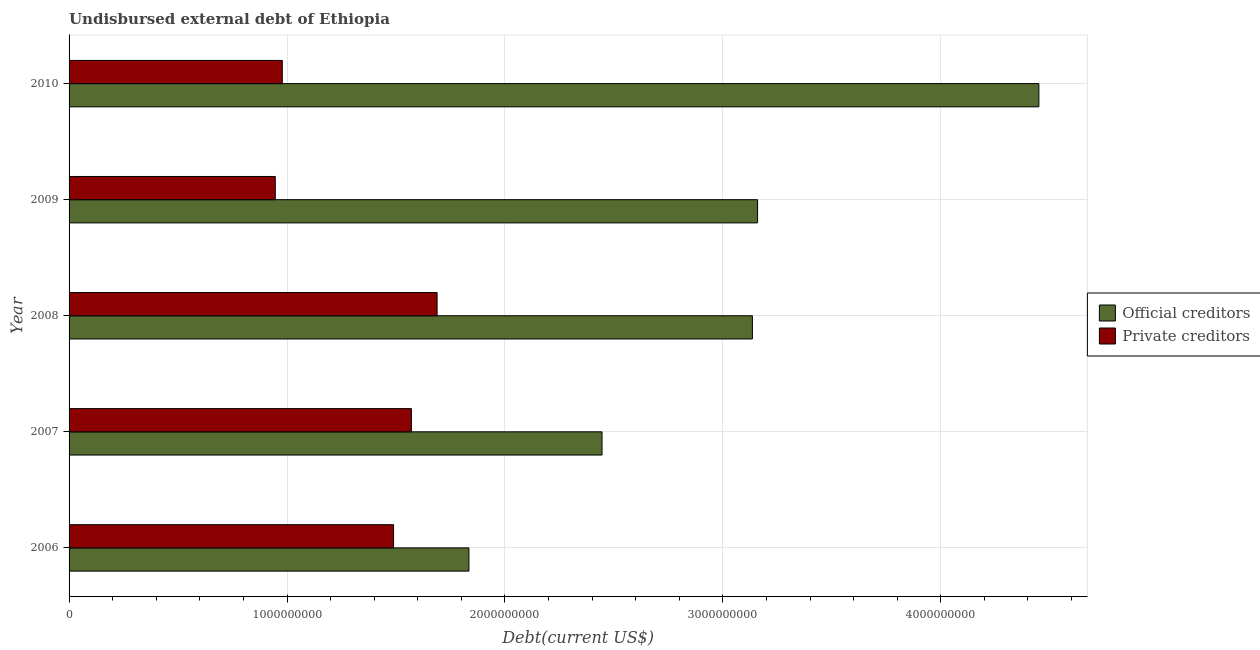How many groups of bars are there?
Provide a succinct answer. 5. Are the number of bars on each tick of the Y-axis equal?
Ensure brevity in your answer.  Yes. How many bars are there on the 5th tick from the top?
Offer a terse response. 2. What is the label of the 5th group of bars from the top?
Your answer should be very brief. 2006. In how many cases, is the number of bars for a given year not equal to the number of legend labels?
Your answer should be very brief. 0. What is the undisbursed external debt of private creditors in 2009?
Provide a short and direct response. 9.46e+08. Across all years, what is the maximum undisbursed external debt of private creditors?
Offer a terse response. 1.69e+09. Across all years, what is the minimum undisbursed external debt of private creditors?
Provide a short and direct response. 9.46e+08. In which year was the undisbursed external debt of private creditors maximum?
Your answer should be very brief. 2008. In which year was the undisbursed external debt of private creditors minimum?
Your answer should be compact. 2009. What is the total undisbursed external debt of private creditors in the graph?
Provide a succinct answer. 6.67e+09. What is the difference between the undisbursed external debt of official creditors in 2007 and that in 2008?
Give a very brief answer. -6.90e+08. What is the difference between the undisbursed external debt of private creditors in 2010 and the undisbursed external debt of official creditors in 2008?
Offer a terse response. -2.16e+09. What is the average undisbursed external debt of official creditors per year?
Provide a short and direct response. 3.00e+09. In the year 2006, what is the difference between the undisbursed external debt of private creditors and undisbursed external debt of official creditors?
Keep it short and to the point. -3.46e+08. In how many years, is the undisbursed external debt of official creditors greater than 1600000000 US$?
Offer a terse response. 5. What is the ratio of the undisbursed external debt of private creditors in 2008 to that in 2009?
Ensure brevity in your answer.  1.78. What is the difference between the highest and the second highest undisbursed external debt of private creditors?
Provide a short and direct response. 1.18e+08. What is the difference between the highest and the lowest undisbursed external debt of official creditors?
Offer a very short reply. 2.62e+09. Is the sum of the undisbursed external debt of private creditors in 2006 and 2010 greater than the maximum undisbursed external debt of official creditors across all years?
Offer a very short reply. No. What does the 2nd bar from the top in 2006 represents?
Your answer should be compact. Official creditors. What does the 2nd bar from the bottom in 2008 represents?
Offer a terse response. Private creditors. How many bars are there?
Provide a succinct answer. 10. How many years are there in the graph?
Ensure brevity in your answer.  5. What is the title of the graph?
Your answer should be very brief. Undisbursed external debt of Ethiopia. What is the label or title of the X-axis?
Offer a terse response. Debt(current US$). What is the Debt(current US$) of Official creditors in 2006?
Offer a terse response. 1.83e+09. What is the Debt(current US$) of Private creditors in 2006?
Provide a succinct answer. 1.49e+09. What is the Debt(current US$) of Official creditors in 2007?
Offer a terse response. 2.45e+09. What is the Debt(current US$) of Private creditors in 2007?
Your response must be concise. 1.57e+09. What is the Debt(current US$) of Official creditors in 2008?
Provide a short and direct response. 3.14e+09. What is the Debt(current US$) in Private creditors in 2008?
Offer a terse response. 1.69e+09. What is the Debt(current US$) in Official creditors in 2009?
Your response must be concise. 3.16e+09. What is the Debt(current US$) of Private creditors in 2009?
Offer a very short reply. 9.46e+08. What is the Debt(current US$) in Official creditors in 2010?
Make the answer very short. 4.45e+09. What is the Debt(current US$) of Private creditors in 2010?
Your answer should be very brief. 9.78e+08. Across all years, what is the maximum Debt(current US$) of Official creditors?
Your answer should be very brief. 4.45e+09. Across all years, what is the maximum Debt(current US$) in Private creditors?
Provide a short and direct response. 1.69e+09. Across all years, what is the minimum Debt(current US$) of Official creditors?
Your response must be concise. 1.83e+09. Across all years, what is the minimum Debt(current US$) of Private creditors?
Ensure brevity in your answer.  9.46e+08. What is the total Debt(current US$) in Official creditors in the graph?
Your answer should be very brief. 1.50e+1. What is the total Debt(current US$) in Private creditors in the graph?
Your answer should be compact. 6.67e+09. What is the difference between the Debt(current US$) in Official creditors in 2006 and that in 2007?
Your response must be concise. -6.11e+08. What is the difference between the Debt(current US$) of Private creditors in 2006 and that in 2007?
Provide a short and direct response. -8.19e+07. What is the difference between the Debt(current US$) of Official creditors in 2006 and that in 2008?
Your response must be concise. -1.30e+09. What is the difference between the Debt(current US$) in Private creditors in 2006 and that in 2008?
Offer a terse response. -2.00e+08. What is the difference between the Debt(current US$) in Official creditors in 2006 and that in 2009?
Ensure brevity in your answer.  -1.32e+09. What is the difference between the Debt(current US$) in Private creditors in 2006 and that in 2009?
Provide a short and direct response. 5.43e+08. What is the difference between the Debt(current US$) of Official creditors in 2006 and that in 2010?
Offer a very short reply. -2.62e+09. What is the difference between the Debt(current US$) in Private creditors in 2006 and that in 2010?
Give a very brief answer. 5.10e+08. What is the difference between the Debt(current US$) in Official creditors in 2007 and that in 2008?
Make the answer very short. -6.90e+08. What is the difference between the Debt(current US$) in Private creditors in 2007 and that in 2008?
Offer a terse response. -1.18e+08. What is the difference between the Debt(current US$) of Official creditors in 2007 and that in 2009?
Give a very brief answer. -7.14e+08. What is the difference between the Debt(current US$) in Private creditors in 2007 and that in 2009?
Keep it short and to the point. 6.25e+08. What is the difference between the Debt(current US$) of Official creditors in 2007 and that in 2010?
Offer a terse response. -2.00e+09. What is the difference between the Debt(current US$) of Private creditors in 2007 and that in 2010?
Offer a very short reply. 5.92e+08. What is the difference between the Debt(current US$) of Official creditors in 2008 and that in 2009?
Your response must be concise. -2.38e+07. What is the difference between the Debt(current US$) in Private creditors in 2008 and that in 2009?
Keep it short and to the point. 7.42e+08. What is the difference between the Debt(current US$) in Official creditors in 2008 and that in 2010?
Your response must be concise. -1.31e+09. What is the difference between the Debt(current US$) in Private creditors in 2008 and that in 2010?
Offer a terse response. 7.10e+08. What is the difference between the Debt(current US$) in Official creditors in 2009 and that in 2010?
Your answer should be very brief. -1.29e+09. What is the difference between the Debt(current US$) of Private creditors in 2009 and that in 2010?
Your answer should be very brief. -3.22e+07. What is the difference between the Debt(current US$) in Official creditors in 2006 and the Debt(current US$) in Private creditors in 2007?
Make the answer very short. 2.64e+08. What is the difference between the Debt(current US$) in Official creditors in 2006 and the Debt(current US$) in Private creditors in 2008?
Ensure brevity in your answer.  1.46e+08. What is the difference between the Debt(current US$) in Official creditors in 2006 and the Debt(current US$) in Private creditors in 2009?
Offer a very short reply. 8.89e+08. What is the difference between the Debt(current US$) in Official creditors in 2006 and the Debt(current US$) in Private creditors in 2010?
Offer a very short reply. 8.56e+08. What is the difference between the Debt(current US$) of Official creditors in 2007 and the Debt(current US$) of Private creditors in 2008?
Provide a short and direct response. 7.57e+08. What is the difference between the Debt(current US$) in Official creditors in 2007 and the Debt(current US$) in Private creditors in 2009?
Offer a very short reply. 1.50e+09. What is the difference between the Debt(current US$) of Official creditors in 2007 and the Debt(current US$) of Private creditors in 2010?
Provide a short and direct response. 1.47e+09. What is the difference between the Debt(current US$) of Official creditors in 2008 and the Debt(current US$) of Private creditors in 2009?
Provide a succinct answer. 2.19e+09. What is the difference between the Debt(current US$) of Official creditors in 2008 and the Debt(current US$) of Private creditors in 2010?
Provide a short and direct response. 2.16e+09. What is the difference between the Debt(current US$) of Official creditors in 2009 and the Debt(current US$) of Private creditors in 2010?
Your answer should be very brief. 2.18e+09. What is the average Debt(current US$) in Official creditors per year?
Provide a short and direct response. 3.00e+09. What is the average Debt(current US$) in Private creditors per year?
Your response must be concise. 1.33e+09. In the year 2006, what is the difference between the Debt(current US$) of Official creditors and Debt(current US$) of Private creditors?
Your answer should be compact. 3.46e+08. In the year 2007, what is the difference between the Debt(current US$) in Official creditors and Debt(current US$) in Private creditors?
Offer a very short reply. 8.75e+08. In the year 2008, what is the difference between the Debt(current US$) of Official creditors and Debt(current US$) of Private creditors?
Your answer should be compact. 1.45e+09. In the year 2009, what is the difference between the Debt(current US$) of Official creditors and Debt(current US$) of Private creditors?
Provide a succinct answer. 2.21e+09. In the year 2010, what is the difference between the Debt(current US$) in Official creditors and Debt(current US$) in Private creditors?
Ensure brevity in your answer.  3.47e+09. What is the ratio of the Debt(current US$) in Official creditors in 2006 to that in 2007?
Your answer should be very brief. 0.75. What is the ratio of the Debt(current US$) in Private creditors in 2006 to that in 2007?
Offer a very short reply. 0.95. What is the ratio of the Debt(current US$) in Official creditors in 2006 to that in 2008?
Your answer should be compact. 0.59. What is the ratio of the Debt(current US$) in Private creditors in 2006 to that in 2008?
Give a very brief answer. 0.88. What is the ratio of the Debt(current US$) of Official creditors in 2006 to that in 2009?
Keep it short and to the point. 0.58. What is the ratio of the Debt(current US$) of Private creditors in 2006 to that in 2009?
Your answer should be very brief. 1.57. What is the ratio of the Debt(current US$) in Official creditors in 2006 to that in 2010?
Give a very brief answer. 0.41. What is the ratio of the Debt(current US$) of Private creditors in 2006 to that in 2010?
Offer a terse response. 1.52. What is the ratio of the Debt(current US$) of Official creditors in 2007 to that in 2008?
Make the answer very short. 0.78. What is the ratio of the Debt(current US$) in Private creditors in 2007 to that in 2008?
Offer a terse response. 0.93. What is the ratio of the Debt(current US$) in Official creditors in 2007 to that in 2009?
Keep it short and to the point. 0.77. What is the ratio of the Debt(current US$) in Private creditors in 2007 to that in 2009?
Give a very brief answer. 1.66. What is the ratio of the Debt(current US$) of Official creditors in 2007 to that in 2010?
Provide a short and direct response. 0.55. What is the ratio of the Debt(current US$) in Private creditors in 2007 to that in 2010?
Offer a very short reply. 1.61. What is the ratio of the Debt(current US$) of Official creditors in 2008 to that in 2009?
Provide a short and direct response. 0.99. What is the ratio of the Debt(current US$) of Private creditors in 2008 to that in 2009?
Your answer should be compact. 1.78. What is the ratio of the Debt(current US$) of Official creditors in 2008 to that in 2010?
Offer a terse response. 0.7. What is the ratio of the Debt(current US$) in Private creditors in 2008 to that in 2010?
Ensure brevity in your answer.  1.73. What is the ratio of the Debt(current US$) in Official creditors in 2009 to that in 2010?
Your answer should be very brief. 0.71. What is the ratio of the Debt(current US$) in Private creditors in 2009 to that in 2010?
Offer a terse response. 0.97. What is the difference between the highest and the second highest Debt(current US$) in Official creditors?
Keep it short and to the point. 1.29e+09. What is the difference between the highest and the second highest Debt(current US$) in Private creditors?
Your answer should be compact. 1.18e+08. What is the difference between the highest and the lowest Debt(current US$) of Official creditors?
Give a very brief answer. 2.62e+09. What is the difference between the highest and the lowest Debt(current US$) of Private creditors?
Keep it short and to the point. 7.42e+08. 